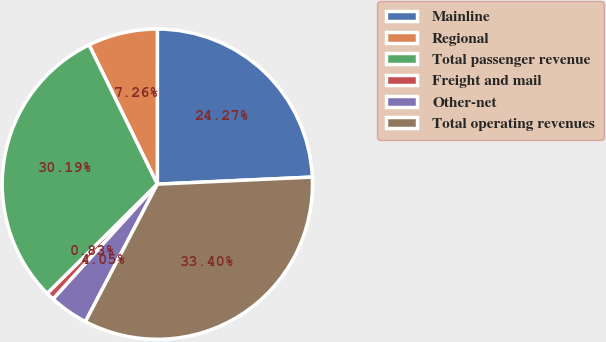Convert chart to OTSL. <chart><loc_0><loc_0><loc_500><loc_500><pie_chart><fcel>Mainline<fcel>Regional<fcel>Total passenger revenue<fcel>Freight and mail<fcel>Other-net<fcel>Total operating revenues<nl><fcel>24.27%<fcel>7.26%<fcel>30.19%<fcel>0.83%<fcel>4.05%<fcel>33.4%<nl></chart> 